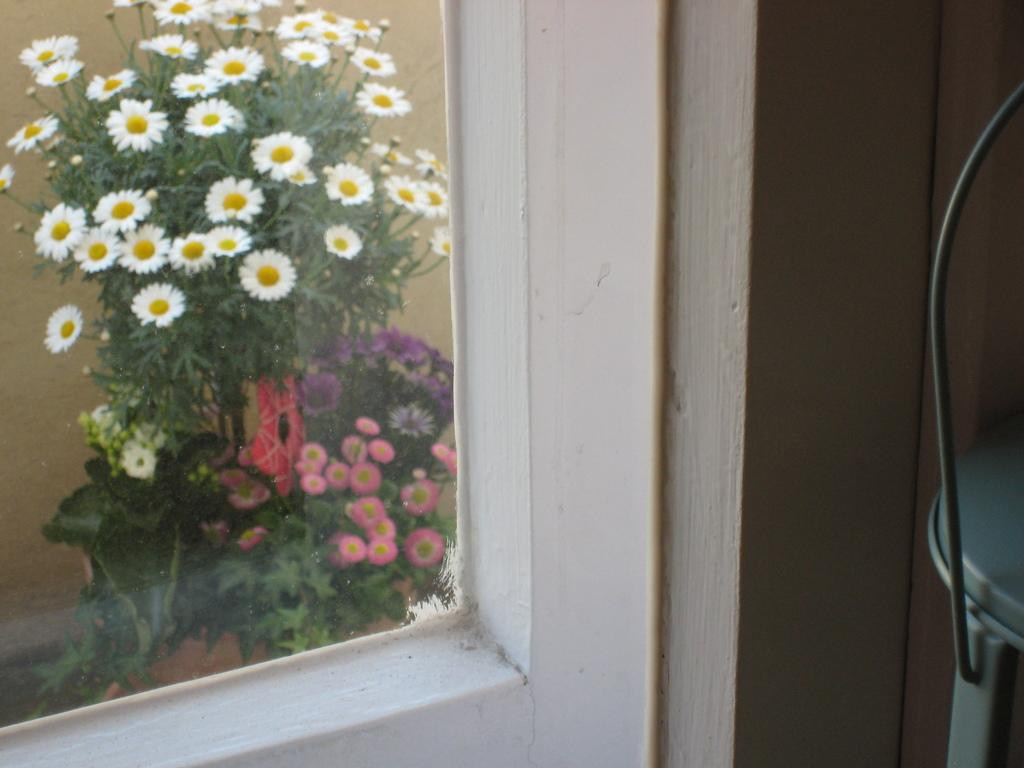What is the main object in the image? There is an object in the image, but its specific nature is not mentioned in the facts. What can be seen on the wall in the image? There is a wall with a glass window in the image. What is visible through the window? Plants with flowers are visible behind the window. How many feet are visible on the object in the image? There is no mention of feet or any object with feet in the image, so this question cannot be answered. 